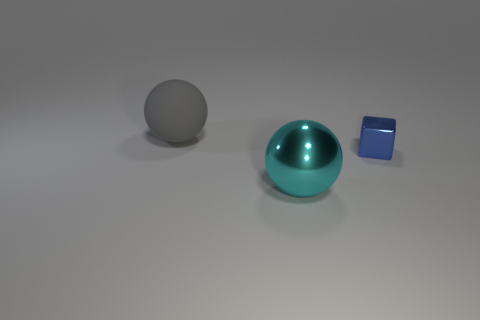Are there any spheres that are right of the large sphere behind the cyan sphere?
Your response must be concise. Yes. The metal block has what size?
Provide a succinct answer. Small. What is the shape of the object that is both right of the rubber ball and behind the large metal ball?
Offer a terse response. Cube. How many green things are either metallic cubes or big matte objects?
Provide a short and direct response. 0. There is a ball that is in front of the rubber ball; is its size the same as the object that is left of the big cyan thing?
Provide a short and direct response. Yes. How many things are either large gray matte spheres or big yellow metallic cylinders?
Ensure brevity in your answer.  1. Is there a cyan shiny thing that has the same shape as the blue shiny thing?
Ensure brevity in your answer.  No. Are there fewer large gray balls than tiny matte objects?
Give a very brief answer. No. Do the tiny blue object and the matte object have the same shape?
Your answer should be compact. No. What number of objects are either large cyan balls or balls that are in front of the small metal object?
Provide a succinct answer. 1. 